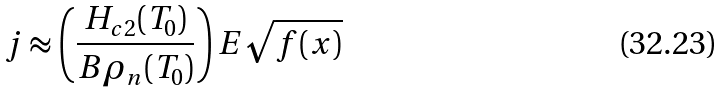<formula> <loc_0><loc_0><loc_500><loc_500>j \approx \left ( \frac { H _ { c 2 } ( T _ { 0 } ) } { B \rho _ { n } ( T _ { 0 } ) } \right ) E \sqrt { f ( x ) }</formula> 